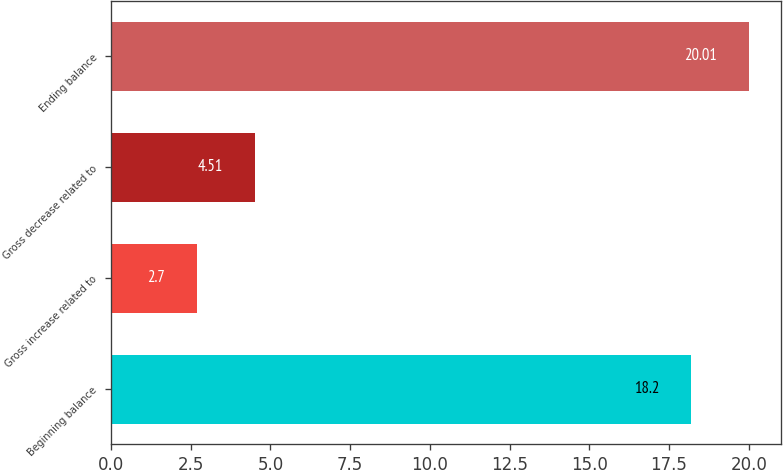Convert chart. <chart><loc_0><loc_0><loc_500><loc_500><bar_chart><fcel>Beginning balance<fcel>Gross increase related to<fcel>Gross decrease related to<fcel>Ending balance<nl><fcel>18.2<fcel>2.7<fcel>4.51<fcel>20.01<nl></chart> 